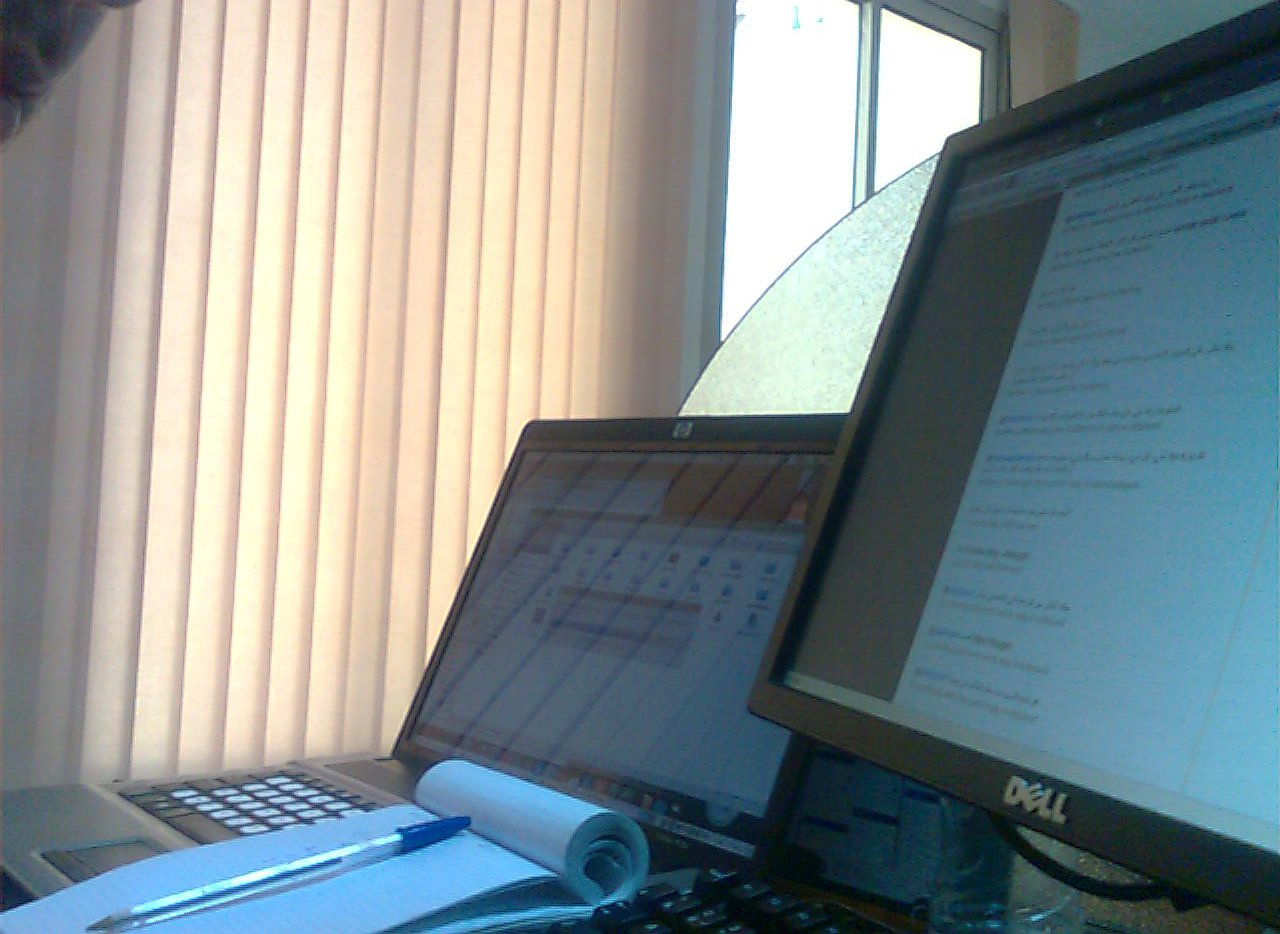Is the pen on a desk? No, the pen is not resting on the desk surface; it's placed upon a notepad. 